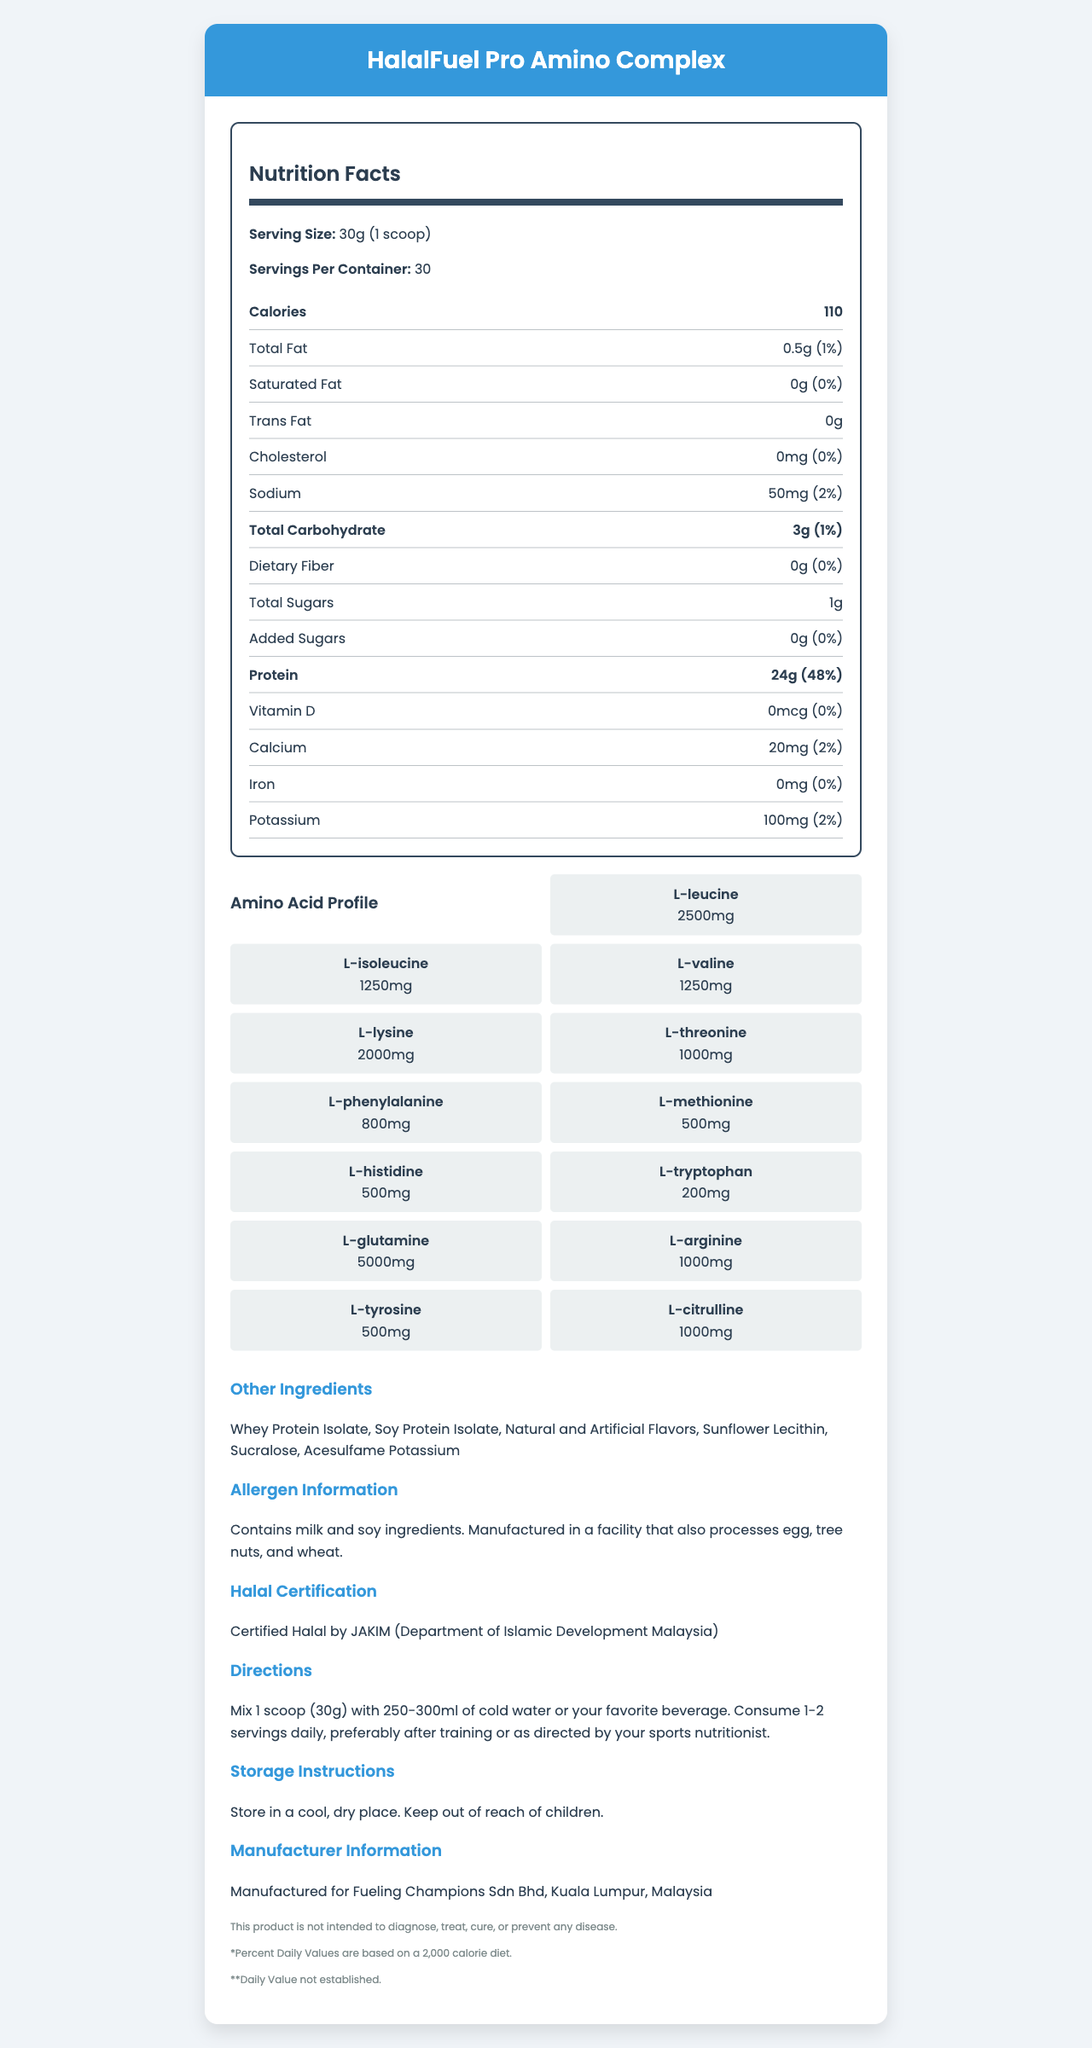which amino acid has the highest amount? The amino acid profile shows that L-Glutamine has 5000mg, which is the highest amount listed.
Answer: L-Glutamine what is the serving size for HalalFuel Pro Amino Complex? The document specifies that the serving size is 30g, which is equivalent to 1 scoop.
Answer: 30g (1 scoop) how many calories are there per serving? According to the Nutrition Facts, each serving contains 110 calories.
Answer: 110 calories is there any cholesterol in this supplement? The Nutrition Facts show that the amount of cholesterol is 0mg, which means there is no cholesterol in this supplement.
Answer: No does this product contain any dietary fiber? The Nutrition Facts indicate that the amount of dietary fiber is 0g.
Answer: No which certification does this product have? A. ISO B. Halal by JAKIM C. FDA The document states that the product is Certified Halal by JAKIM (Department of Islamic Development Malaysia).
Answer: B what is the total carbohydrate per serving? The Nutrition Facts list the total carbohydrate content per serving as 3g.
Answer: 3g are there any added sugars in this product? A. Yes B. No The Nutrition Facts state that the amount of added sugars is 0g.
Answer: B name two amino acids included in the amino acid profile. The amino acid profile lists L-Leucine with 2500mg and L-Isoleucine with 1250mg.
Answer: L-Leucine and L-Isoleucine does this product contain any soy ingredients? The allergen information states that the product contains soy ingredients.
Answer: Yes what is the total protein per serving and its daily value percentage? The Nutrition Facts show that protein content is 24g per serving, which is 48% of the daily value.
Answer: 24g, 48% where is the manufacturer located? The manufacturer information indicates that the product is manufactured by Fueling Champions Sdn Bhd in Kuala Lumpur, Malaysia.
Answer: Kuala Lumpur, Malaysia summarize the main idea of the document. The document contains comprehensive details organized into sections focused on nutrition, ingredients, certification, and usage to help users understand the product and its benefits.
Answer: The document provides detailed nutritional and product information for HalalFuel Pro Amino Complex, a halal-certified sports supplement powder. It includes serving size, nutritional facts, amino acid profile, other ingredients, allergen information, directions for use, storage instructions, and manufacturer details. what is the content of trans fat in this supplement? The Nutrition Facts clearly state that the trans fat content is 0g.
Answer: 0g what is the potassium content per serving? The Nutrition Facts show that there are 100mg of potassium per serving.
Answer: 100mg where should you store this product? The storage instructions advise storing the product in a cool, dry place.
Answer: In a cool, dry place does the nutrition facts label mention any information about vitamins? If yes, which vitamin is mentioned? The Nutrition Facts mention that Vitamin D is present, but the amount is 0mcg.
Answer: Vitamin D can this product diagnose, treat, cure, or prevent any disease? The disclaimers section states that the product is not intended to diagnose, treat, cure, or prevent any disease.
Answer: No is this product suitable for vegetarians? The document does not provide any information specifically indicating whether the product is suitable for vegetarians.
Answer: Cannot be determined 